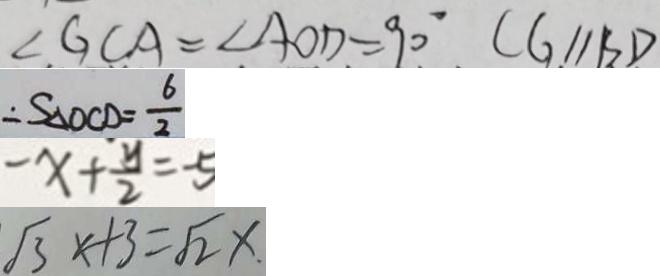<formula> <loc_0><loc_0><loc_500><loc_500>\angle G C A = \angle A O D = 9 0 ^ { \circ } C G / / B D 
 \therefore S _ { \Delta O C D } = \frac { 6 } { 2 } 
 - x + \frac { y } { 2 } = - 5 
 \sqrt { 3 } x + 3 = \sqrt { 2 } x</formula> 